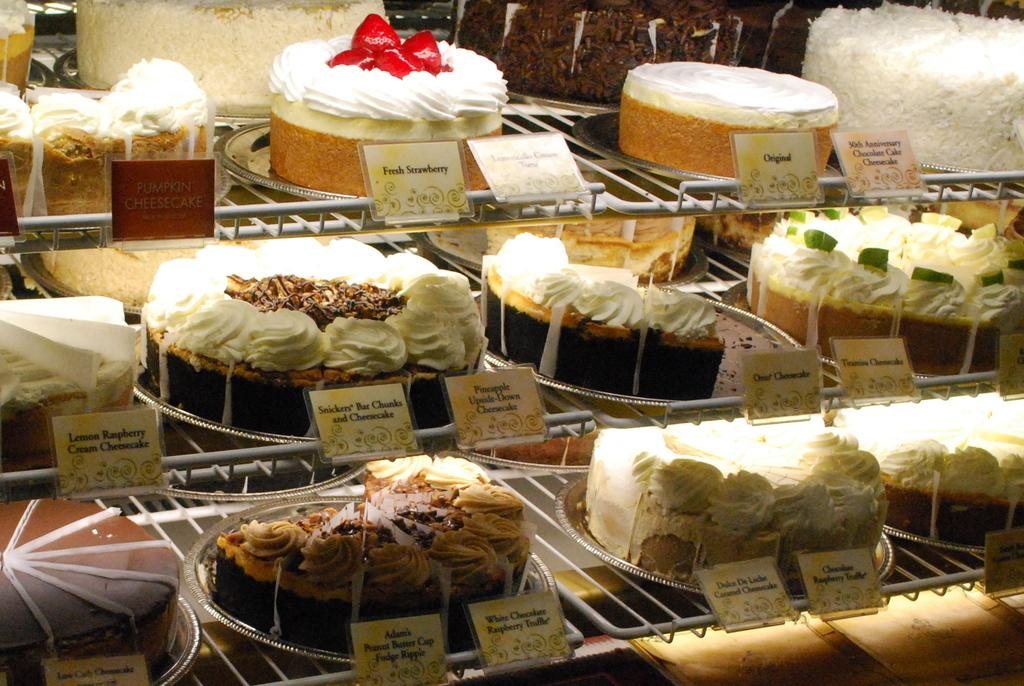What type of food items are visible in the image? There are cakes in the image. What else can be seen on the shelves besides the cakes? There are cards in the image. How are the cakes and cards arranged in the image? The cakes and cards are arranged on shelves. What type of flight is depicted in the image? There is no flight depicted in the image; it features cakes and cards arranged on shelves. What appliance is used to prepare the cakes in the image? There is no appliance visible in the image, as it only shows the cakes and cards on shelves. 